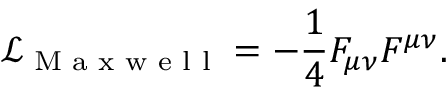Convert formula to latex. <formula><loc_0><loc_0><loc_500><loc_500>\mathcal { L } _ { M a x w e l l } = - \frac { 1 } { 4 } F _ { \mu \nu } F ^ { \mu \nu } .</formula> 